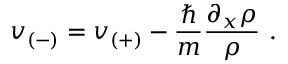Convert formula to latex. <formula><loc_0><loc_0><loc_500><loc_500>v _ { ( - ) } = v _ { ( + ) } - \frac { } { m } \frac { \partial _ { x } \rho } { \rho } \, .</formula> 